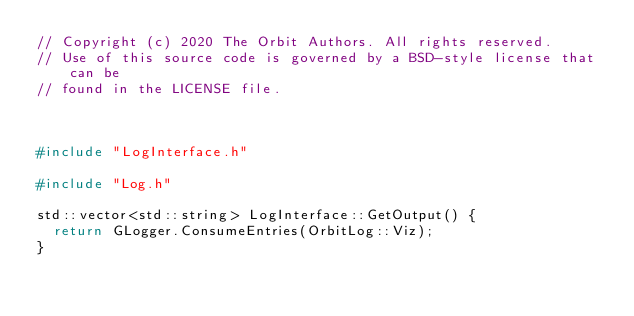<code> <loc_0><loc_0><loc_500><loc_500><_C++_>// Copyright (c) 2020 The Orbit Authors. All rights reserved.
// Use of this source code is governed by a BSD-style license that can be
// found in the LICENSE file.



#include "LogInterface.h"

#include "Log.h"

std::vector<std::string> LogInterface::GetOutput() {
  return GLogger.ConsumeEntries(OrbitLog::Viz);
}</code> 